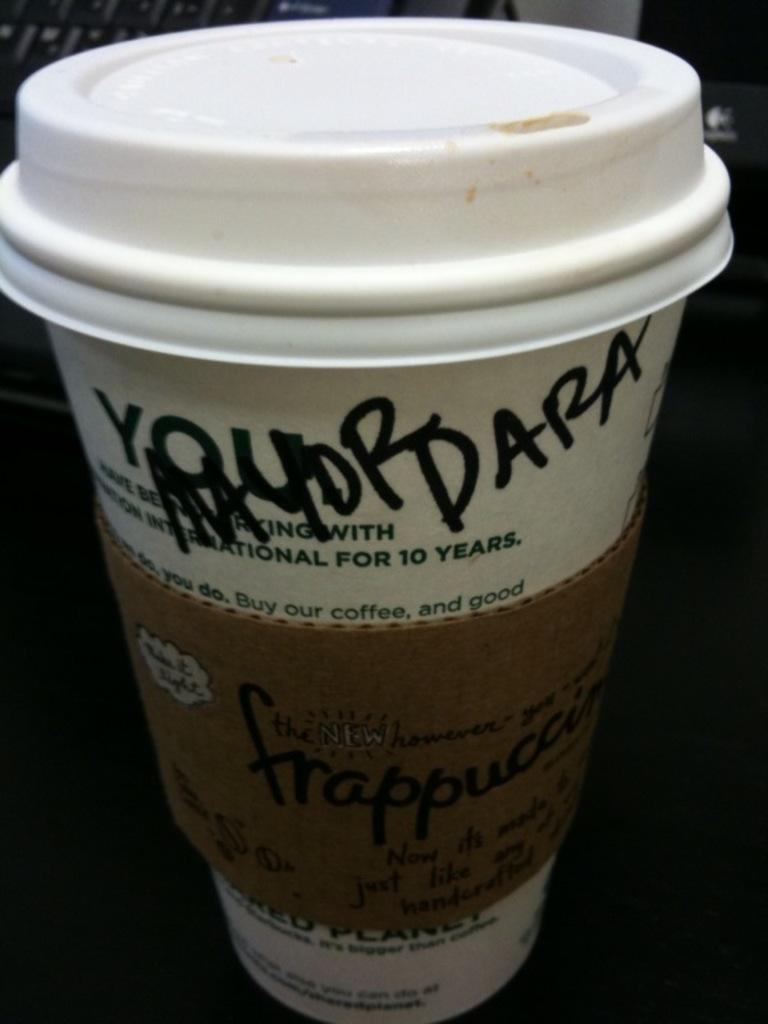What is present in the image? There is a cup in the image. What type of linen can be seen draped over the cup in the image? There is no linen draped over the cup in the image. What kind of toys are visible in the image? There are no toys present in the image. 